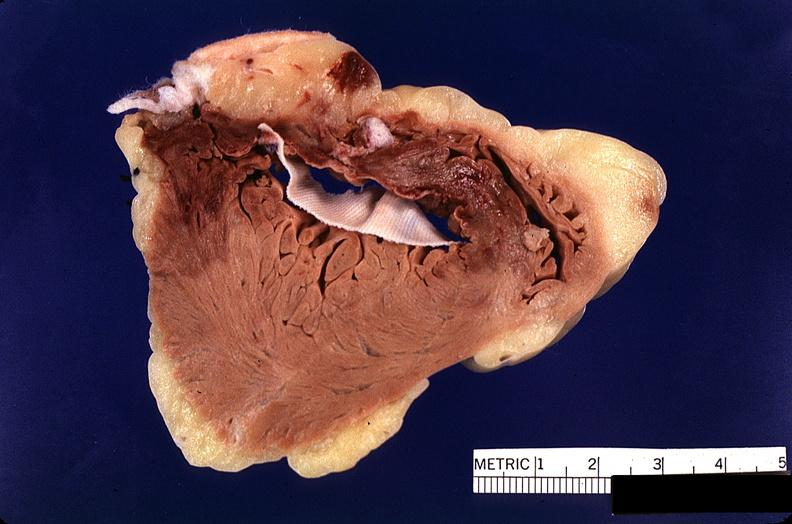s nodular tumor present?
Answer the question using a single word or phrase. No 